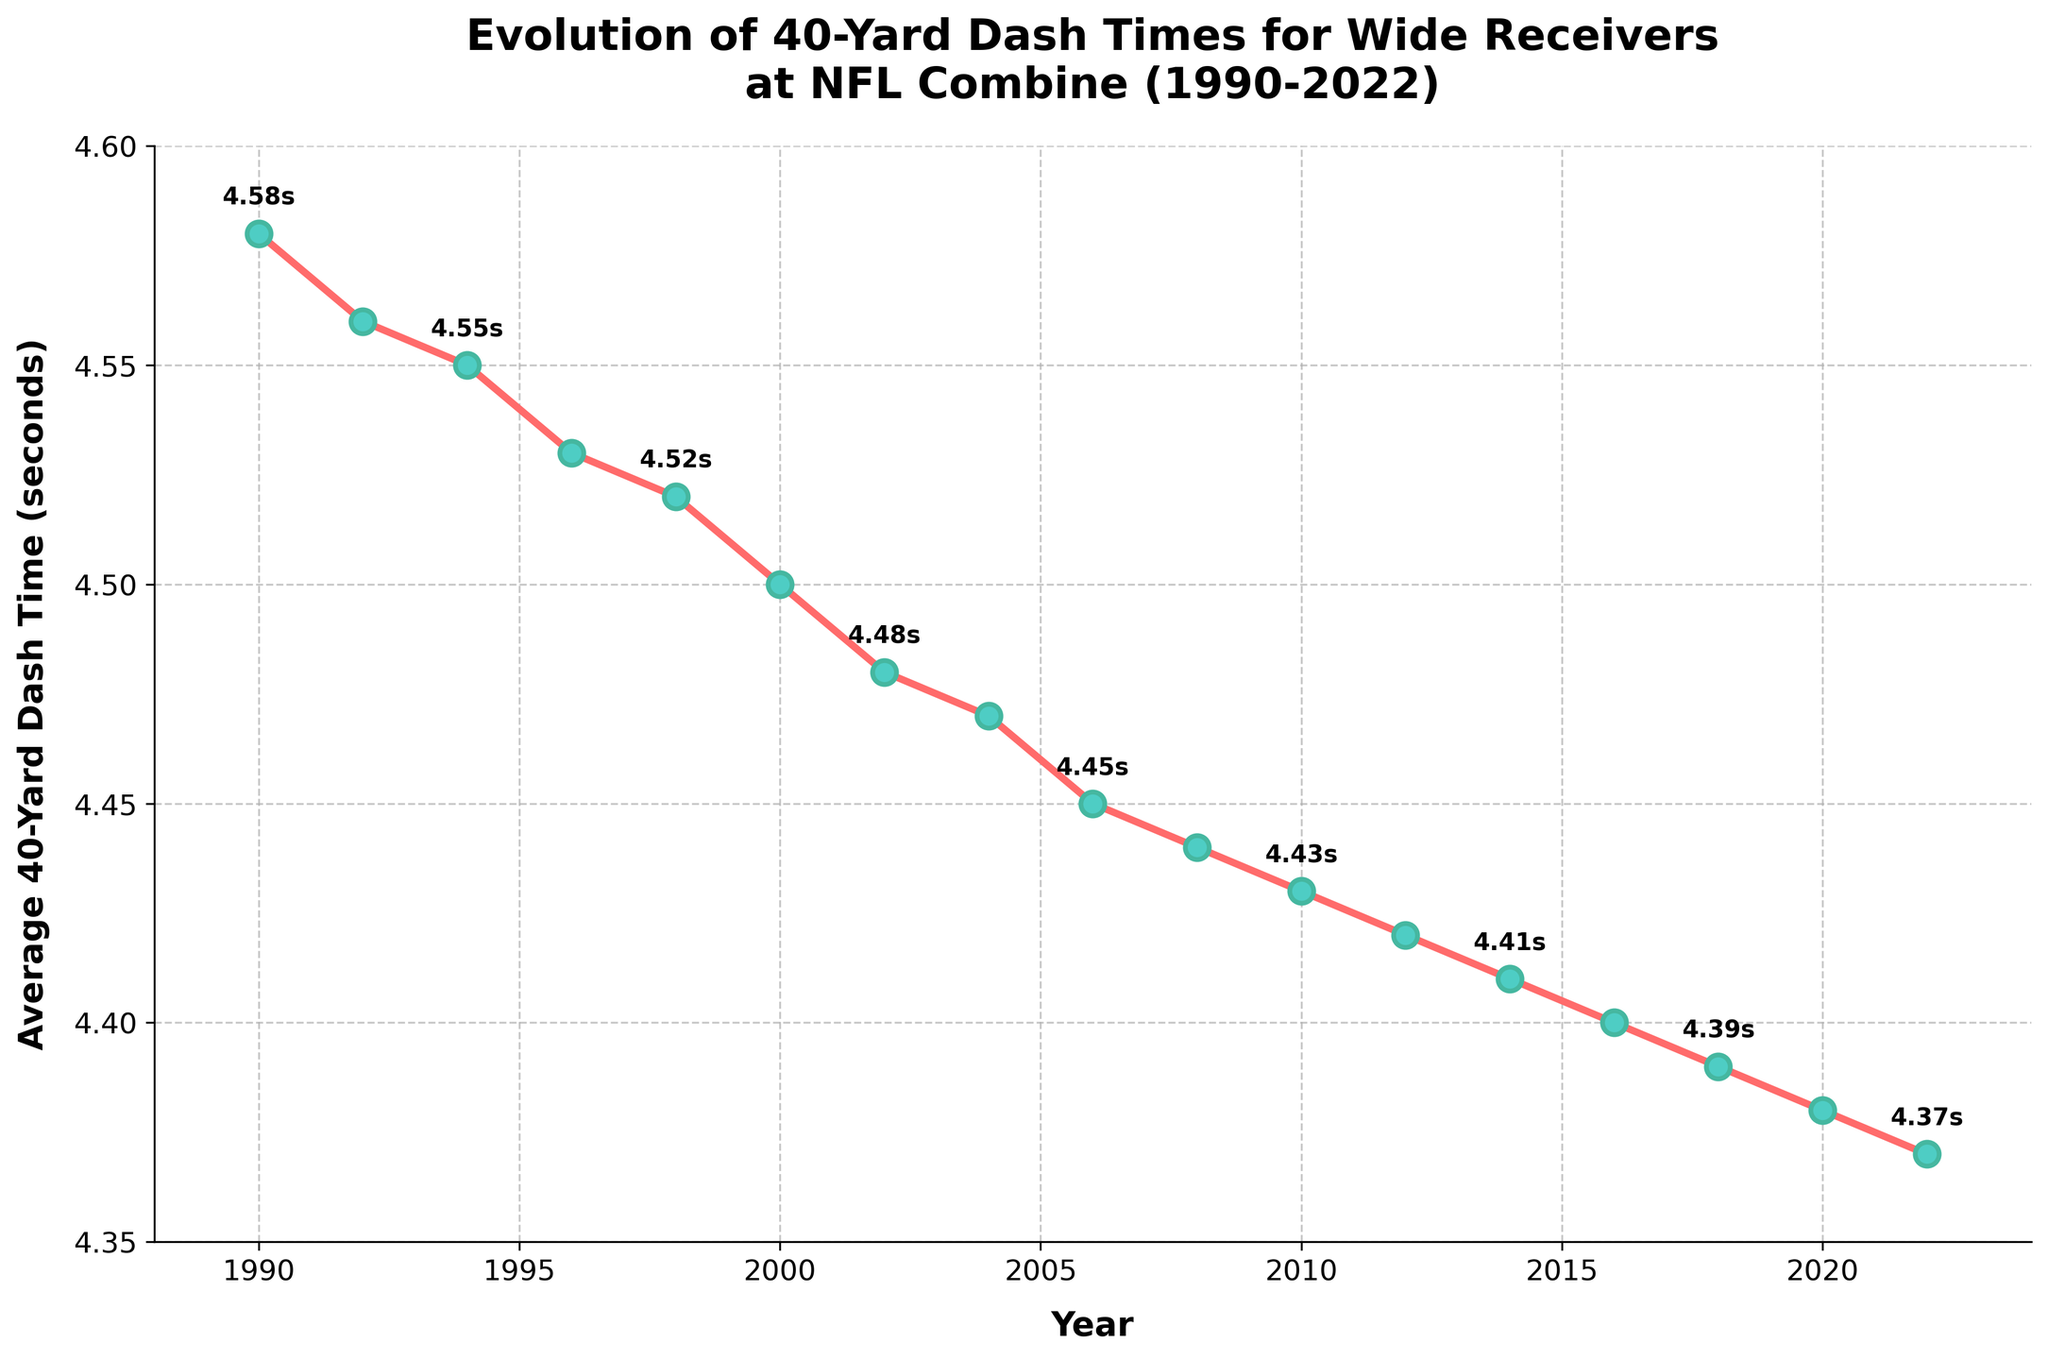What's the average 40-yard dash time in the 1990s? To calculate the average time in the 1990s, sum up the times from 1990, 1992, 1994, 1996, and 1998: (4.58 + 4.56 + 4.55 + 4.53 + 4.52) = 22.74. Then, divide by the number of data points, which is 5. So, 22.74 / 5 = 4.548 seconds.
Answer: 4.548 seconds In which year did wide receivers record the fastest average 40-yard dash time? By looking at the line chart, the lowest point on the plot corresponds to the fastest time, which is 4.37 seconds in 2022.
Answer: 2022 How much did the average 40-yard dash time decrease from 1990 to 2022? The average time in 1990 was 4.58 seconds, and in 2022, it is 4.37 seconds. The difference is 4.58 - 4.37 = 0.21 seconds.
Answer: 0.21 seconds What is the trend of the average 40-yard dash times from 1990 to 2022? Observing the overall shape of the line, the average 40-yard dash times show a decreasing trend from 1990 to 2022, indicating an improvement in speed.
Answer: Decreasing Which period saw the most significant improvement in average 40-yard dash times, 1990-2000 or 2010-2020? In the period 1990-2000, the time decreased from 4.58 seconds to 4.50 seconds, a difference of 0.08 seconds. In the period 2010-2020, the time decreased from 4.43 seconds to 4.38 seconds, a difference of 0.05 seconds. Therefore, 1990-2000 saw the most significant improvement.
Answer: 1990-2000 What is the average 40-yard dash time improvement per decade? Calculate the average time for each decade: 1990s average = (4.58 + 4.56 + 4.55 + 4.53 + 4.52)/5 = 4.548 seconds; 2000s average = (4.50 + 4.48 + 4.47 + 4.45 + 4.44)/5 = 4.468 seconds; 2010s average = (4.43 + 4.42 + 4.41 + 4.40 + 4.39)/5 = 4.41 seconds; 2020s: (4.38 + 4.37)/2 = 4.375 seconds. The improvement per decade is calculated by subtracting consecutive averages: 4.548 - 4.468 = 0.08; 4.468 - 4.41 = 0.058; 4.41 - 4.375 = 0.035. Average improvement per decade = (0.08 + 0.058 + 0.035)/3 = 0.0577 seconds.
Answer: 0.0577 seconds Which year is midpoint in the observed trend of the average 40-yard dash times? The midway point of the period 1990-2022 is 2006. In that year, the average 40-yard dash time is 4.45 seconds.
Answer: 2006 How many times did the average 40-yard dash time improve by more than 0.01 seconds compared to the previous recorded year? Going through the difference between each consecutive year in the data, we count the instances where the improvement is greater than 0.01 seconds. These instances are: 1990-1992, 1992-1994, 1994-1996, 1996-1998, 1998-2000, 2002-2004, 2004-2006, 2006-2008, 2008-2010. This happens 9 times.
Answer: 9 times 